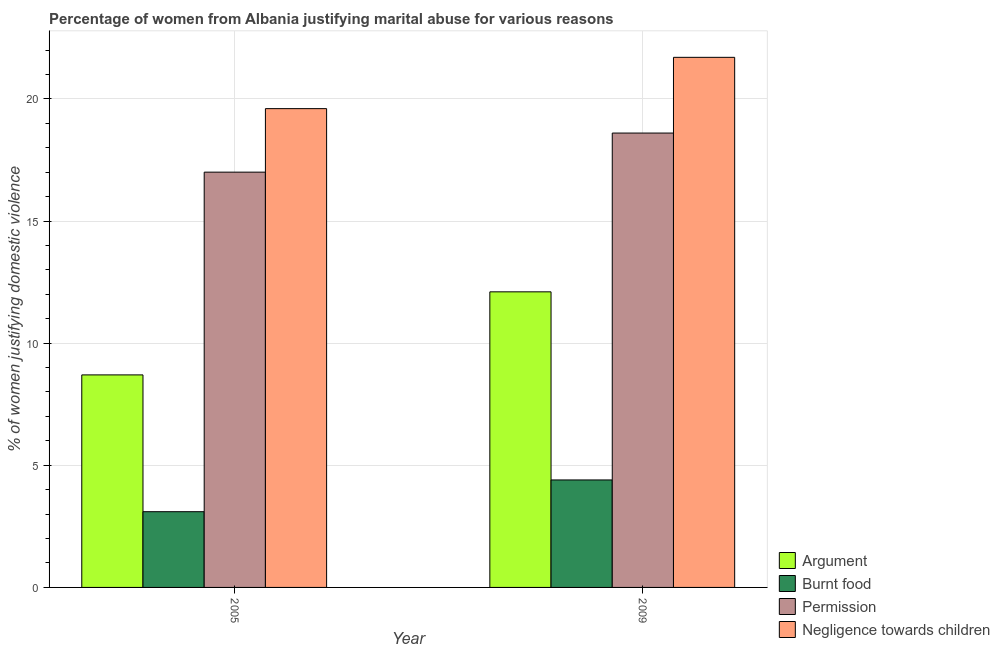How many groups of bars are there?
Provide a short and direct response. 2. Are the number of bars on each tick of the X-axis equal?
Offer a terse response. Yes. How many bars are there on the 1st tick from the left?
Offer a terse response. 4. How many bars are there on the 1st tick from the right?
Provide a short and direct response. 4. What is the label of the 2nd group of bars from the left?
Offer a terse response. 2009. What is the percentage of women justifying abuse for going without permission in 2005?
Your answer should be very brief. 17. Across all years, what is the minimum percentage of women justifying abuse for showing negligence towards children?
Keep it short and to the point. 19.6. What is the total percentage of women justifying abuse in the case of an argument in the graph?
Offer a very short reply. 20.8. What is the difference between the percentage of women justifying abuse for burning food in 2005 and that in 2009?
Make the answer very short. -1.3. What is the difference between the percentage of women justifying abuse for going without permission in 2005 and the percentage of women justifying abuse for burning food in 2009?
Make the answer very short. -1.6. What is the average percentage of women justifying abuse for burning food per year?
Make the answer very short. 3.75. In the year 2009, what is the difference between the percentage of women justifying abuse for burning food and percentage of women justifying abuse in the case of an argument?
Ensure brevity in your answer.  0. In how many years, is the percentage of women justifying abuse in the case of an argument greater than 3 %?
Make the answer very short. 2. What is the ratio of the percentage of women justifying abuse for showing negligence towards children in 2005 to that in 2009?
Ensure brevity in your answer.  0.9. Is it the case that in every year, the sum of the percentage of women justifying abuse for burning food and percentage of women justifying abuse in the case of an argument is greater than the sum of percentage of women justifying abuse for going without permission and percentage of women justifying abuse for showing negligence towards children?
Your response must be concise. No. What does the 2nd bar from the left in 2009 represents?
Your answer should be very brief. Burnt food. What does the 3rd bar from the right in 2005 represents?
Your answer should be very brief. Burnt food. How many years are there in the graph?
Make the answer very short. 2. Are the values on the major ticks of Y-axis written in scientific E-notation?
Your response must be concise. No. How many legend labels are there?
Your answer should be very brief. 4. How are the legend labels stacked?
Provide a succinct answer. Vertical. What is the title of the graph?
Your response must be concise. Percentage of women from Albania justifying marital abuse for various reasons. Does "Overall level" appear as one of the legend labels in the graph?
Your answer should be very brief. No. What is the label or title of the X-axis?
Your answer should be compact. Year. What is the label or title of the Y-axis?
Offer a very short reply. % of women justifying domestic violence. What is the % of women justifying domestic violence of Negligence towards children in 2005?
Your answer should be very brief. 19.6. What is the % of women justifying domestic violence in Argument in 2009?
Ensure brevity in your answer.  12.1. What is the % of women justifying domestic violence in Burnt food in 2009?
Keep it short and to the point. 4.4. What is the % of women justifying domestic violence of Permission in 2009?
Offer a terse response. 18.6. What is the % of women justifying domestic violence in Negligence towards children in 2009?
Ensure brevity in your answer.  21.7. Across all years, what is the maximum % of women justifying domestic violence in Argument?
Your answer should be compact. 12.1. Across all years, what is the maximum % of women justifying domestic violence of Permission?
Offer a terse response. 18.6. Across all years, what is the maximum % of women justifying domestic violence of Negligence towards children?
Your response must be concise. 21.7. Across all years, what is the minimum % of women justifying domestic violence in Argument?
Your answer should be compact. 8.7. Across all years, what is the minimum % of women justifying domestic violence in Permission?
Your response must be concise. 17. Across all years, what is the minimum % of women justifying domestic violence of Negligence towards children?
Your response must be concise. 19.6. What is the total % of women justifying domestic violence in Argument in the graph?
Your answer should be compact. 20.8. What is the total % of women justifying domestic violence in Permission in the graph?
Offer a very short reply. 35.6. What is the total % of women justifying domestic violence of Negligence towards children in the graph?
Keep it short and to the point. 41.3. What is the difference between the % of women justifying domestic violence of Burnt food in 2005 and that in 2009?
Keep it short and to the point. -1.3. What is the difference between the % of women justifying domestic violence in Permission in 2005 and that in 2009?
Your answer should be very brief. -1.6. What is the difference between the % of women justifying domestic violence of Negligence towards children in 2005 and that in 2009?
Provide a short and direct response. -2.1. What is the difference between the % of women justifying domestic violence in Argument in 2005 and the % of women justifying domestic violence in Burnt food in 2009?
Give a very brief answer. 4.3. What is the difference between the % of women justifying domestic violence of Argument in 2005 and the % of women justifying domestic violence of Negligence towards children in 2009?
Make the answer very short. -13. What is the difference between the % of women justifying domestic violence in Burnt food in 2005 and the % of women justifying domestic violence in Permission in 2009?
Provide a short and direct response. -15.5. What is the difference between the % of women justifying domestic violence of Burnt food in 2005 and the % of women justifying domestic violence of Negligence towards children in 2009?
Your answer should be very brief. -18.6. What is the difference between the % of women justifying domestic violence in Permission in 2005 and the % of women justifying domestic violence in Negligence towards children in 2009?
Give a very brief answer. -4.7. What is the average % of women justifying domestic violence in Burnt food per year?
Provide a short and direct response. 3.75. What is the average % of women justifying domestic violence of Permission per year?
Offer a very short reply. 17.8. What is the average % of women justifying domestic violence of Negligence towards children per year?
Provide a succinct answer. 20.65. In the year 2005, what is the difference between the % of women justifying domestic violence in Argument and % of women justifying domestic violence in Burnt food?
Your response must be concise. 5.6. In the year 2005, what is the difference between the % of women justifying domestic violence of Argument and % of women justifying domestic violence of Negligence towards children?
Make the answer very short. -10.9. In the year 2005, what is the difference between the % of women justifying domestic violence in Burnt food and % of women justifying domestic violence in Negligence towards children?
Your answer should be very brief. -16.5. In the year 2009, what is the difference between the % of women justifying domestic violence of Argument and % of women justifying domestic violence of Burnt food?
Your response must be concise. 7.7. In the year 2009, what is the difference between the % of women justifying domestic violence in Burnt food and % of women justifying domestic violence in Negligence towards children?
Offer a terse response. -17.3. What is the ratio of the % of women justifying domestic violence of Argument in 2005 to that in 2009?
Ensure brevity in your answer.  0.72. What is the ratio of the % of women justifying domestic violence of Burnt food in 2005 to that in 2009?
Offer a very short reply. 0.7. What is the ratio of the % of women justifying domestic violence of Permission in 2005 to that in 2009?
Your answer should be compact. 0.91. What is the ratio of the % of women justifying domestic violence in Negligence towards children in 2005 to that in 2009?
Ensure brevity in your answer.  0.9. What is the difference between the highest and the second highest % of women justifying domestic violence of Burnt food?
Offer a terse response. 1.3. What is the difference between the highest and the lowest % of women justifying domestic violence of Argument?
Make the answer very short. 3.4. What is the difference between the highest and the lowest % of women justifying domestic violence in Burnt food?
Offer a terse response. 1.3. What is the difference between the highest and the lowest % of women justifying domestic violence in Permission?
Keep it short and to the point. 1.6. What is the difference between the highest and the lowest % of women justifying domestic violence of Negligence towards children?
Keep it short and to the point. 2.1. 